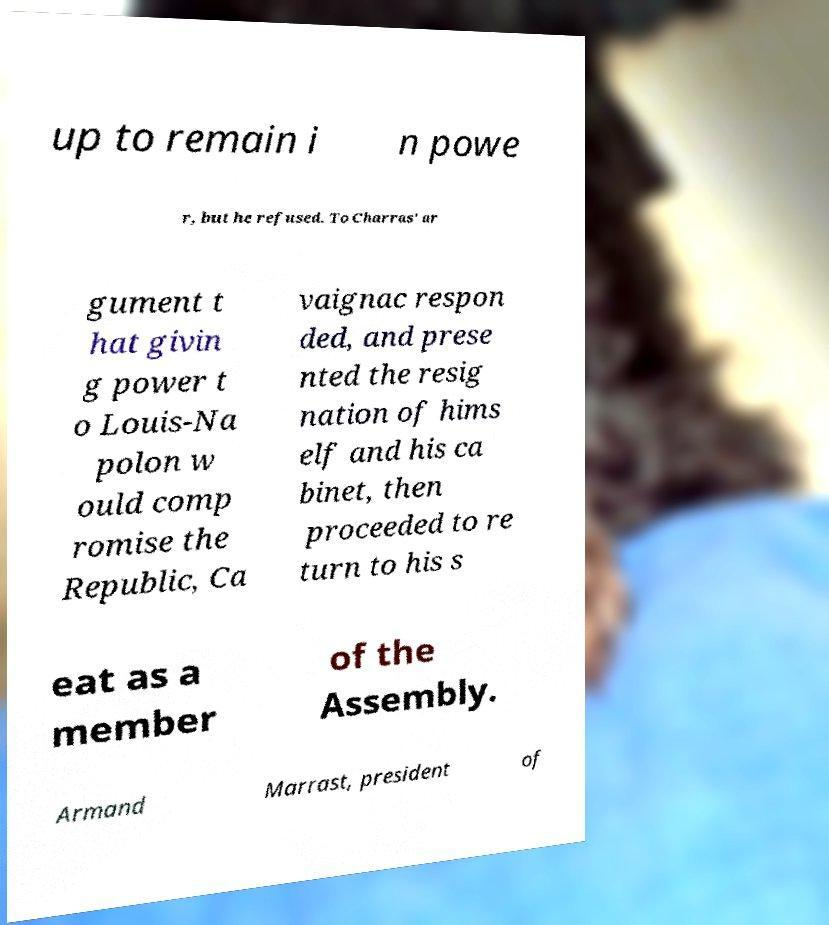There's text embedded in this image that I need extracted. Can you transcribe it verbatim? up to remain i n powe r, but he refused. To Charras' ar gument t hat givin g power t o Louis-Na polon w ould comp romise the Republic, Ca vaignac respon ded, and prese nted the resig nation of hims elf and his ca binet, then proceeded to re turn to his s eat as a member of the Assembly. Armand Marrast, president of 